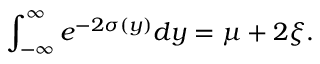Convert formula to latex. <formula><loc_0><loc_0><loc_500><loc_500>\int _ { - \infty } ^ { \infty } e ^ { - 2 \sigma ( y ) } d y = \mu + 2 \xi .</formula> 